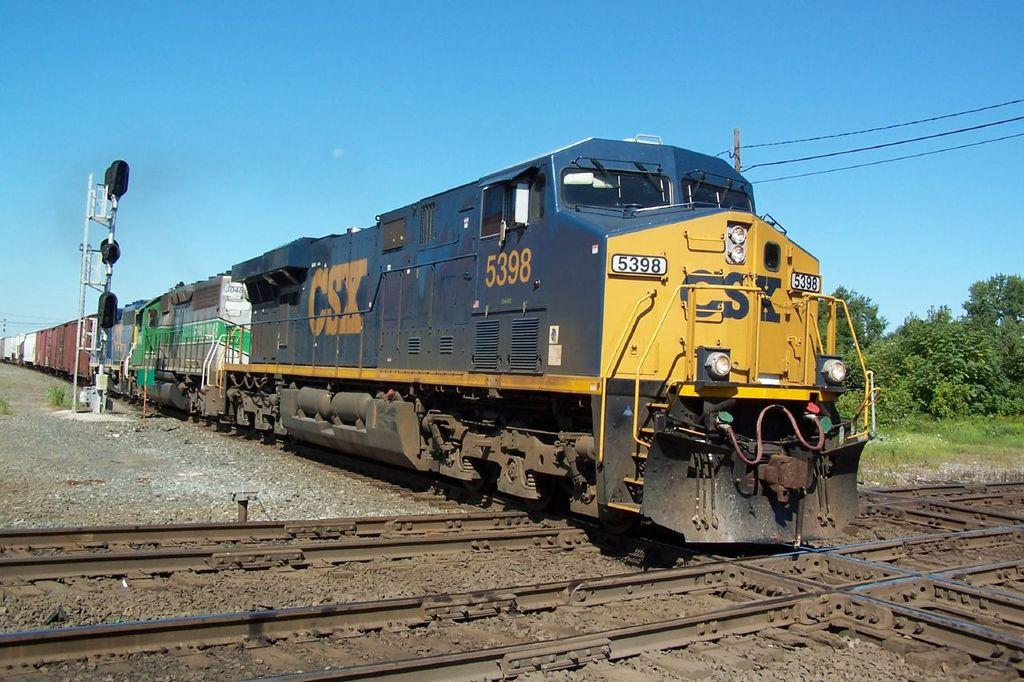What is the main subject of the image? There is a train on the track in the image. What can be seen in the background of the image? There are trees visible in the image. What is attached to the pole in the image? There is a pole with wires in the image. What type of terrain is visible in the image? Stones and grass are visible in the image. How would you describe the weather in the image? The sky is cloudy in the image. Can you tell me how many owls are sitting on the train in the image? There are no owls present in the image; it features a train on the track with trees, a pole with wires, stones, grass, and a cloudy sky. What advice would the father in the image give to his child about the train? There is no father or child present in the image, so it is not possible to answer that question. 